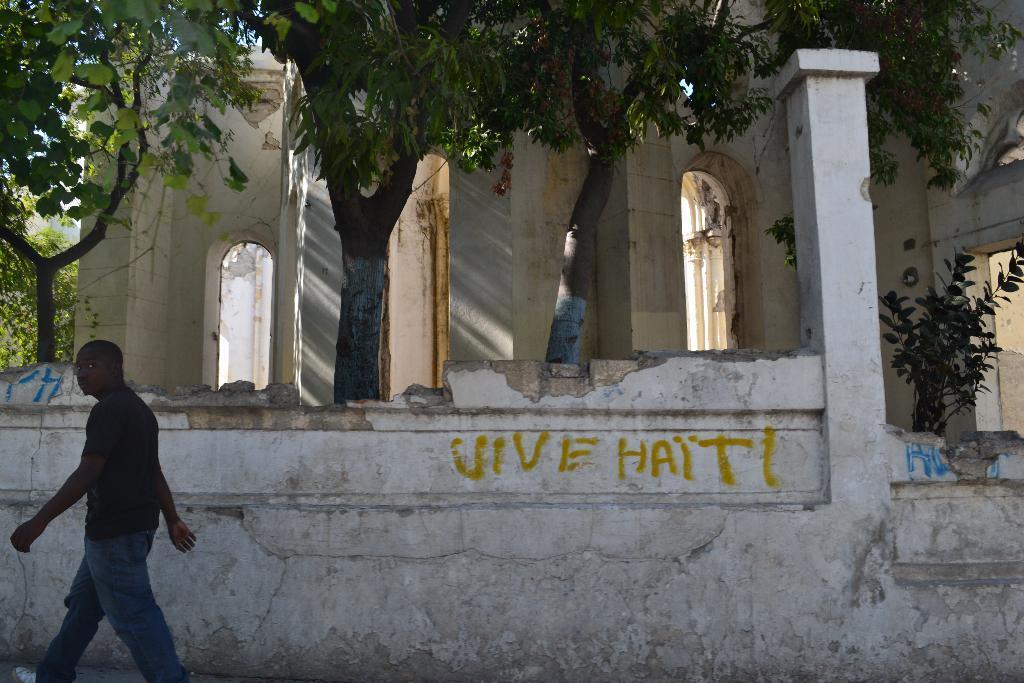Please provide a concise description of this image. In this image, we can see a house with walls. So many trees, plants we can see here. Left side of the image, we can see a person is walking. In the middle of the image, we can see some text on the wall. 